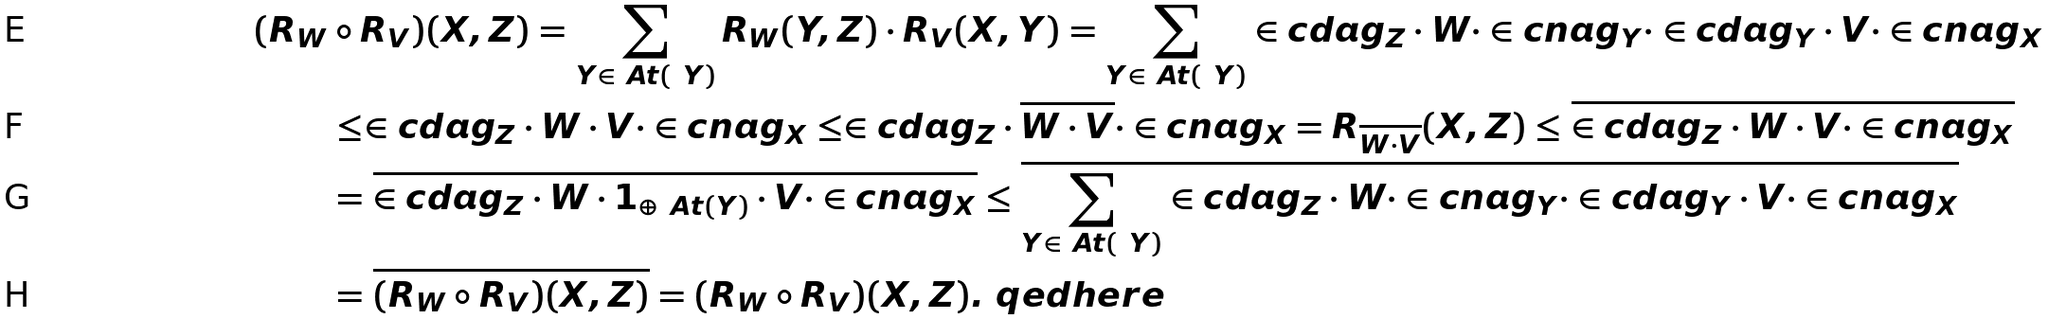Convert formula to latex. <formula><loc_0><loc_0><loc_500><loc_500>( R _ { W } & \circ R _ { V } ) ( X , Z ) = \sum _ { Y \in \ A t ( \ Y ) } R _ { W } ( Y , Z ) \cdot R _ { V } ( X , Y ) = \sum _ { Y \in \ A t ( \ Y ) } \in c d a g _ { Z } \cdot W \cdot \in c n a g _ { Y } \cdot \in c d a g _ { Y } \cdot V \cdot \in c n a g _ { X } \\ & \leq \in c d a g _ { Z } \cdot W \cdot V \cdot \in c n a g _ { X } \leq \in c d a g _ { Z } \cdot \overline { W \cdot V } \cdot \in c n a g _ { X } = R _ { \overline { W \cdot V } } ( X , Z ) \leq \overline { \in c d a g _ { Z } \cdot W \cdot V \cdot \in c n a g _ { X } } \\ & = \overline { \in c d a g _ { Z } \cdot W \cdot 1 _ { \oplus \ A t ( Y ) } \cdot V \cdot \in c n a g _ { X } } \leq \overline { \sum _ { Y \in \ A t ( \ Y ) } \in c d a g _ { Z } \cdot W \cdot \in c n a g _ { Y } \cdot \in c d a g _ { Y } \cdot V \cdot \in c n a g _ { X } } \\ & = \overline { ( R _ { W } \circ R _ { V } ) ( X , Z ) } = ( R _ { W } \circ R _ { V } ) ( X , Z ) . \ q e d h e r e</formula> 